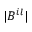Convert formula to latex. <formula><loc_0><loc_0><loc_500><loc_500>| B ^ { i l } |</formula> 